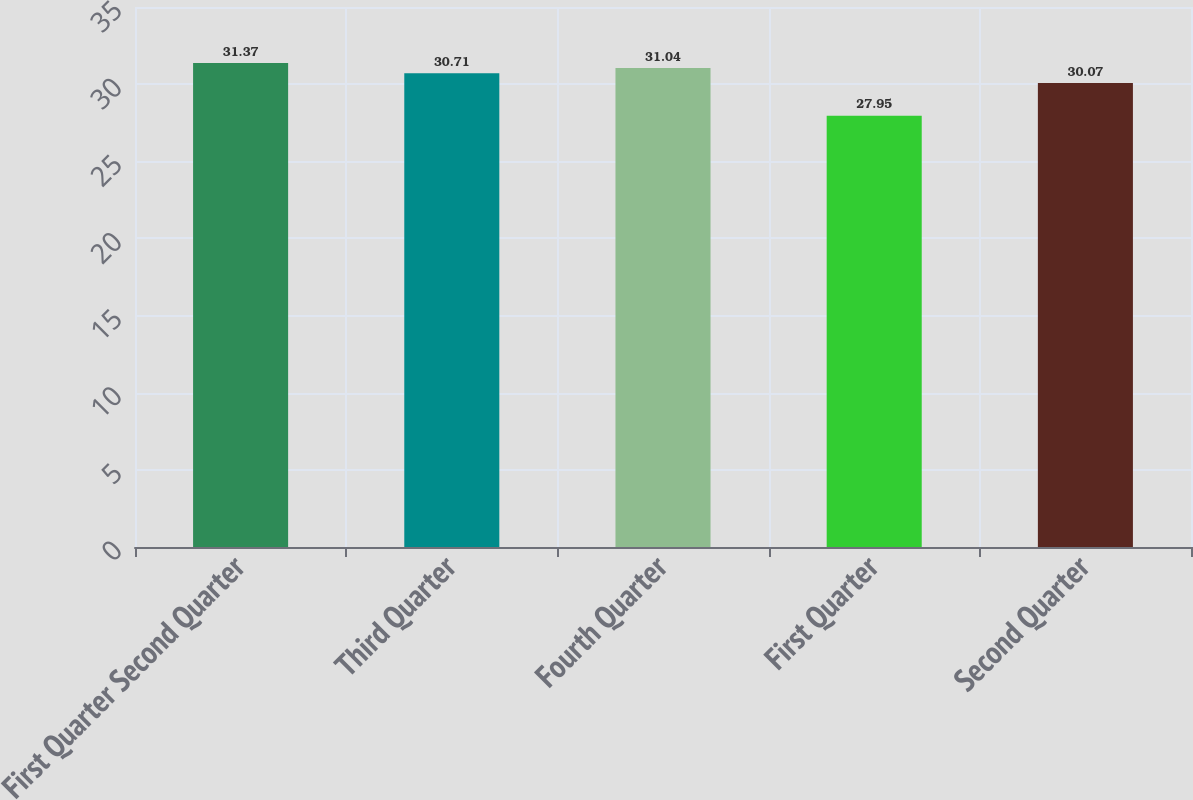Convert chart to OTSL. <chart><loc_0><loc_0><loc_500><loc_500><bar_chart><fcel>First Quarter Second Quarter<fcel>Third Quarter<fcel>Fourth Quarter<fcel>First Quarter<fcel>Second Quarter<nl><fcel>31.37<fcel>30.71<fcel>31.04<fcel>27.95<fcel>30.07<nl></chart> 